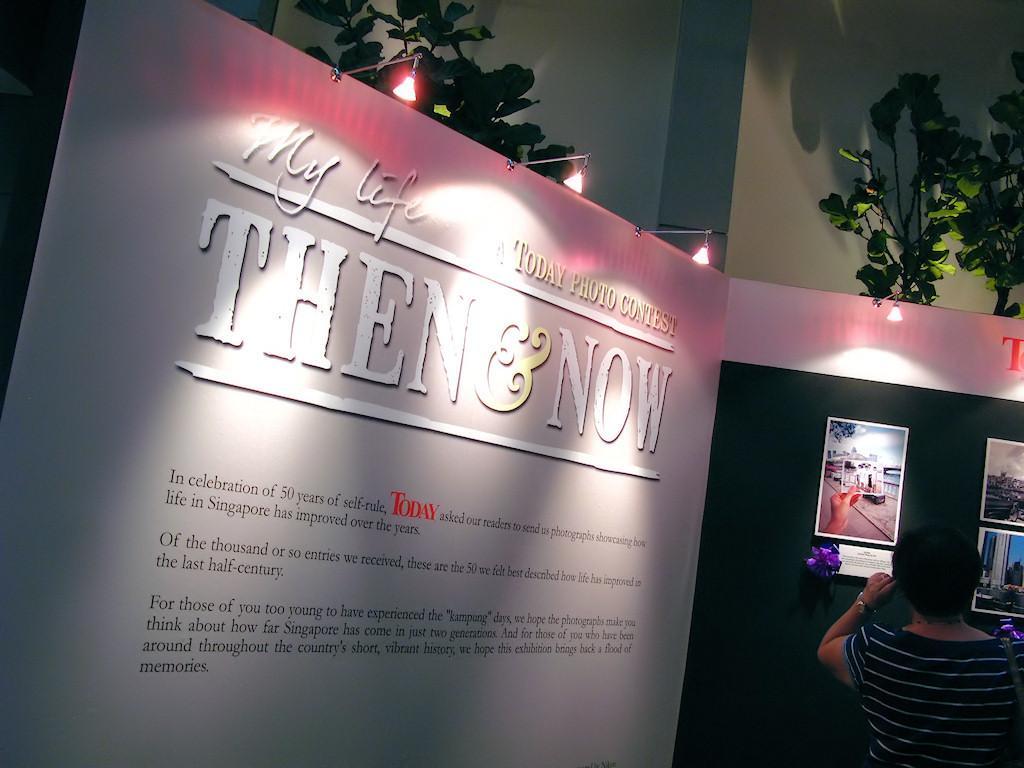Please provide a concise description of this image. In this image we can see a person, hoarding, lights, and trees. On the hoarding we can see pictures and some information. In the background we can see wall. 